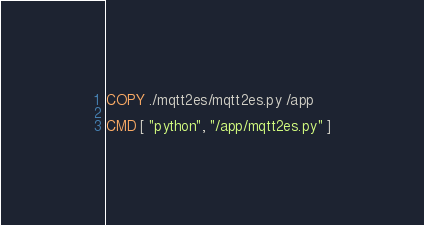<code> <loc_0><loc_0><loc_500><loc_500><_Dockerfile_>COPY ./mqtt2es/mqtt2es.py /app

CMD [ "python", "/app/mqtt2es.py" ]</code> 